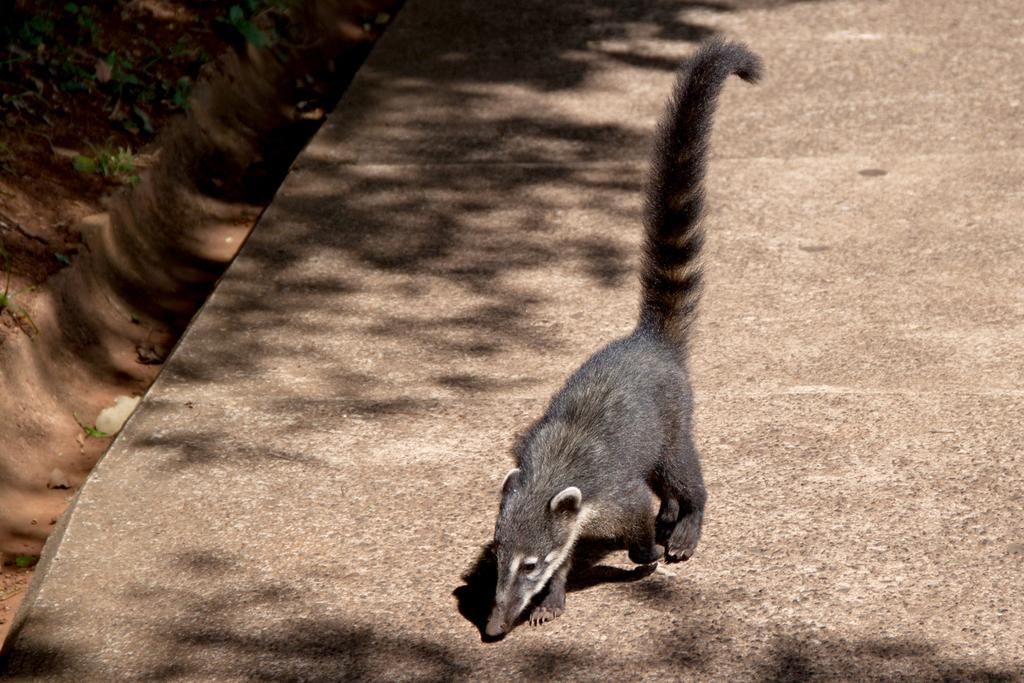What type of living organisms can be seen in the image? Plants can be seen in the image. How many cars are parked next to the plants in the image? There are no cars present in the image; it only features plants. What type of cherry is growing on the plants in the image? There is no cherry plant or fruit visible in the image. 